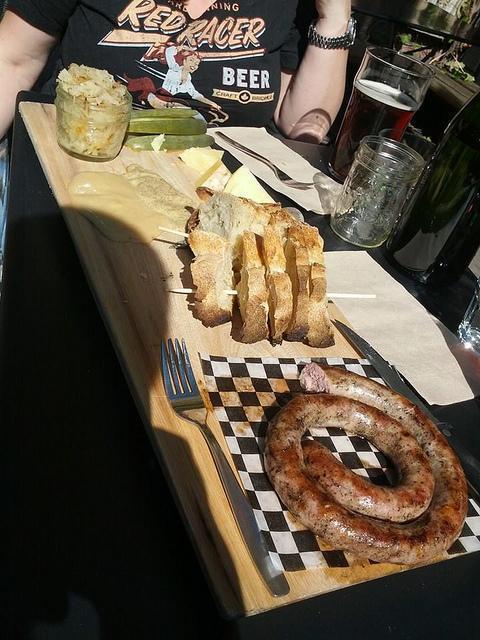Verify the accuracy of this image caption: "The hot dog is at the edge of the dining table.".
Answer yes or no. Yes. 